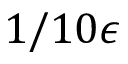<formula> <loc_0><loc_0><loc_500><loc_500>1 / 1 0 \epsilon</formula> 